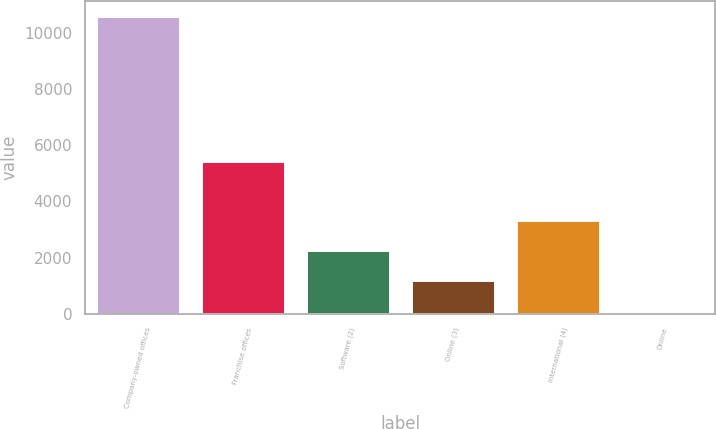Convert chart to OTSL. <chart><loc_0><loc_0><loc_500><loc_500><bar_chart><fcel>Company-owned offices<fcel>Franchise offices<fcel>Software (2)<fcel>Online (3)<fcel>International (4)<fcel>Online<nl><fcel>10608<fcel>5428<fcel>2270.6<fcel>1213<fcel>3328.2<fcel>32<nl></chart> 